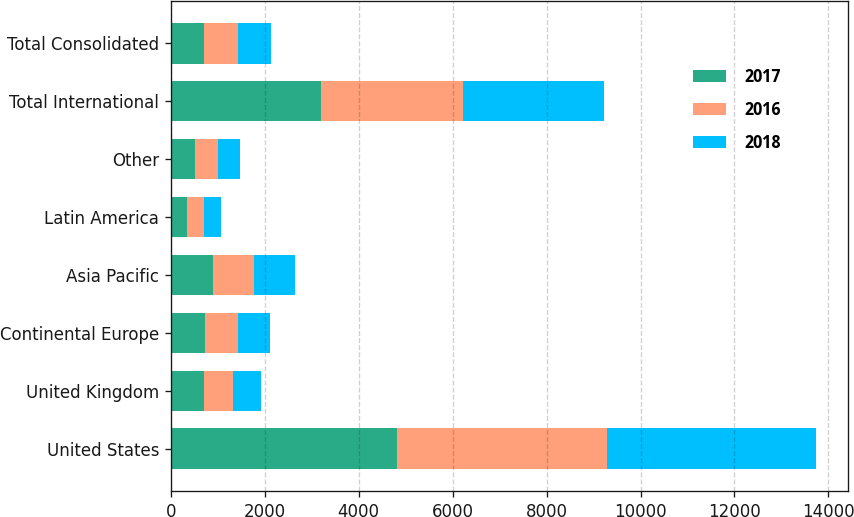<chart> <loc_0><loc_0><loc_500><loc_500><stacked_bar_chart><ecel><fcel>United States<fcel>United Kingdom<fcel>Continental Europe<fcel>Asia Pacific<fcel>Latin America<fcel>Other<fcel>Total International<fcel>Total Consolidated<nl><fcel>2017<fcel>4825<fcel>711.7<fcel>737.5<fcel>896.8<fcel>350.1<fcel>510.5<fcel>3206.6<fcel>711.7<nl><fcel>2016<fcel>4458.8<fcel>613.1<fcel>687.8<fcel>866.9<fcel>350.8<fcel>496.1<fcel>3014.7<fcel>711.7<nl><fcel>2018<fcel>4443.2<fcel>604.3<fcel>682<fcel>887.7<fcel>367.8<fcel>467.3<fcel>3009.1<fcel>711.7<nl></chart> 